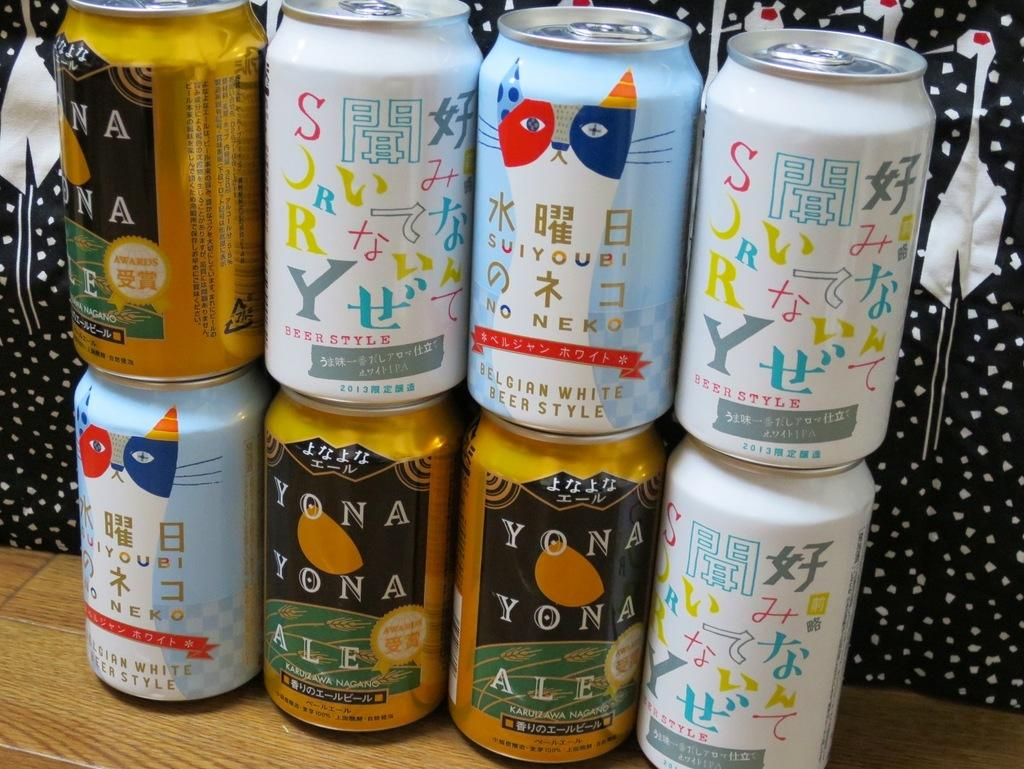<image>
Relay a brief, clear account of the picture shown. An array of beer cans including Belgian White Beer Style. 